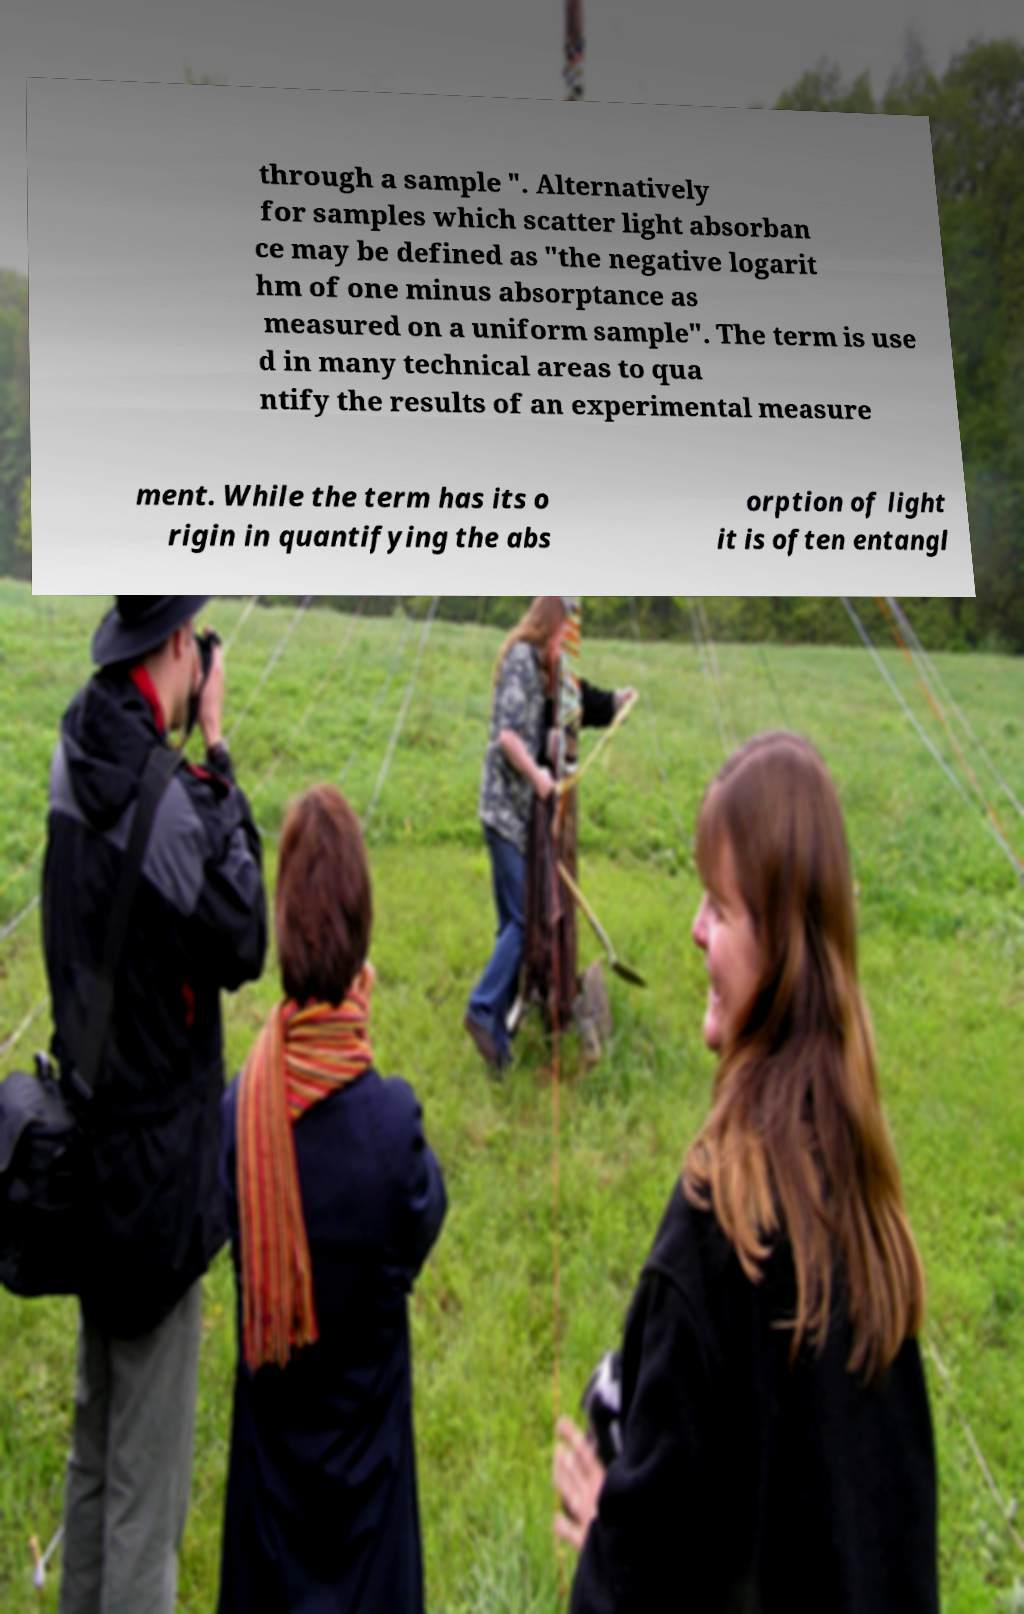Could you assist in decoding the text presented in this image and type it out clearly? through a sample ". Alternatively for samples which scatter light absorban ce may be defined as "the negative logarit hm of one minus absorptance as measured on a uniform sample". The term is use d in many technical areas to qua ntify the results of an experimental measure ment. While the term has its o rigin in quantifying the abs orption of light it is often entangl 